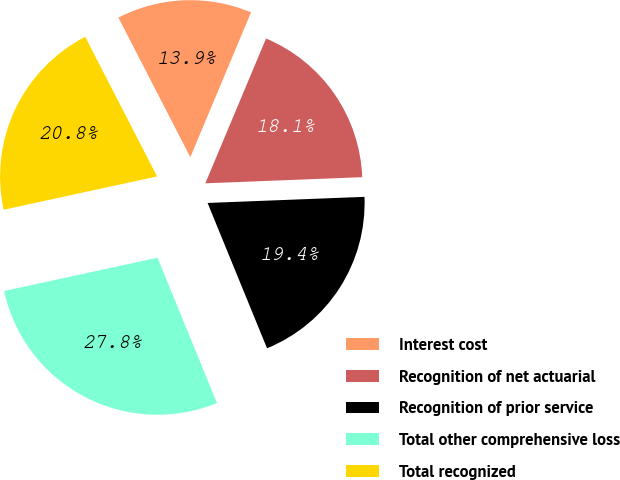Convert chart. <chart><loc_0><loc_0><loc_500><loc_500><pie_chart><fcel>Interest cost<fcel>Recognition of net actuarial<fcel>Recognition of prior service<fcel>Total other comprehensive loss<fcel>Total recognized<nl><fcel>13.89%<fcel>18.06%<fcel>19.44%<fcel>27.78%<fcel>20.83%<nl></chart> 